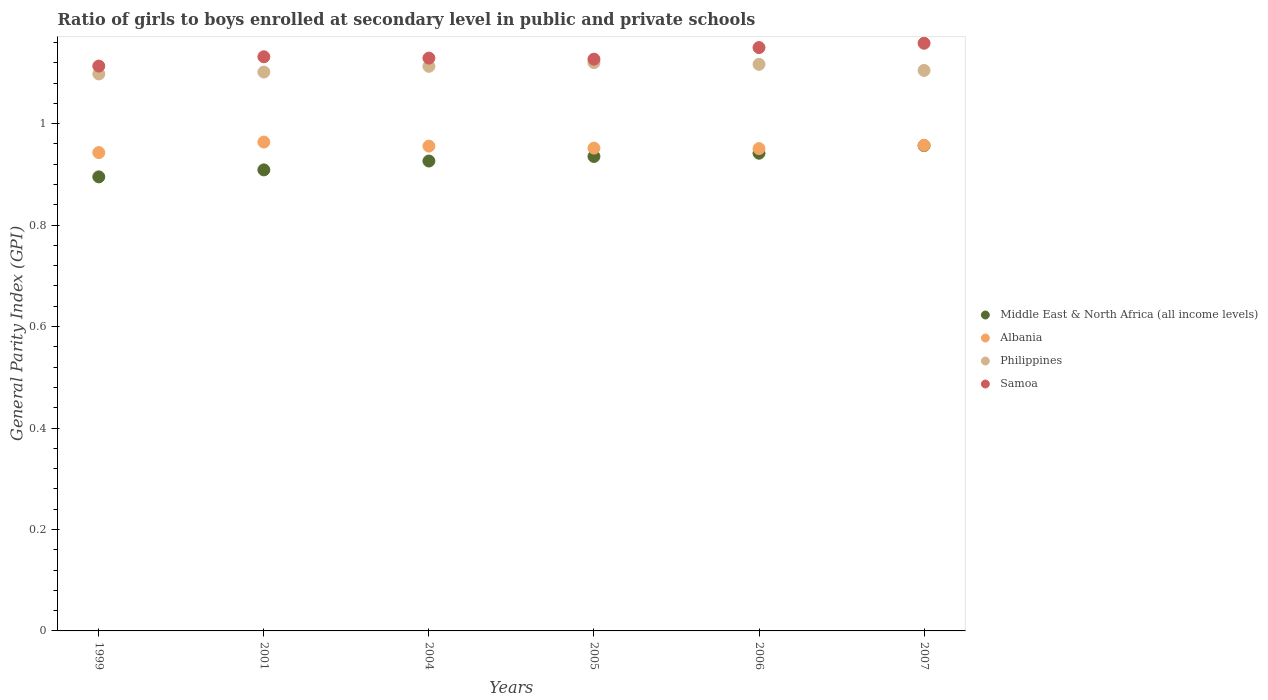What is the general parity index in Samoa in 2005?
Your answer should be compact. 1.13. Across all years, what is the maximum general parity index in Middle East & North Africa (all income levels)?
Your answer should be compact. 0.96. Across all years, what is the minimum general parity index in Middle East & North Africa (all income levels)?
Your answer should be compact. 0.9. What is the total general parity index in Middle East & North Africa (all income levels) in the graph?
Your response must be concise. 5.56. What is the difference between the general parity index in Samoa in 2006 and that in 2007?
Give a very brief answer. -0.01. What is the difference between the general parity index in Philippines in 2005 and the general parity index in Albania in 2007?
Make the answer very short. 0.16. What is the average general parity index in Albania per year?
Offer a very short reply. 0.95. In the year 1999, what is the difference between the general parity index in Philippines and general parity index in Samoa?
Keep it short and to the point. -0.02. What is the ratio of the general parity index in Middle East & North Africa (all income levels) in 2004 to that in 2007?
Your response must be concise. 0.97. Is the general parity index in Middle East & North Africa (all income levels) in 2001 less than that in 2004?
Make the answer very short. Yes. Is the difference between the general parity index in Philippines in 2005 and 2007 greater than the difference between the general parity index in Samoa in 2005 and 2007?
Provide a short and direct response. Yes. What is the difference between the highest and the second highest general parity index in Philippines?
Provide a short and direct response. 0. What is the difference between the highest and the lowest general parity index in Middle East & North Africa (all income levels)?
Provide a succinct answer. 0.06. Is the sum of the general parity index in Philippines in 1999 and 2005 greater than the maximum general parity index in Albania across all years?
Ensure brevity in your answer.  Yes. Is it the case that in every year, the sum of the general parity index in Samoa and general parity index in Philippines  is greater than the sum of general parity index in Middle East & North Africa (all income levels) and general parity index in Albania?
Ensure brevity in your answer.  No. Is the general parity index in Albania strictly greater than the general parity index in Philippines over the years?
Give a very brief answer. No. How many dotlines are there?
Ensure brevity in your answer.  4. Are the values on the major ticks of Y-axis written in scientific E-notation?
Keep it short and to the point. No. Does the graph contain any zero values?
Offer a very short reply. No. Does the graph contain grids?
Provide a succinct answer. No. How many legend labels are there?
Your answer should be very brief. 4. How are the legend labels stacked?
Your answer should be very brief. Vertical. What is the title of the graph?
Give a very brief answer. Ratio of girls to boys enrolled at secondary level in public and private schools. Does "Syrian Arab Republic" appear as one of the legend labels in the graph?
Your answer should be compact. No. What is the label or title of the X-axis?
Offer a terse response. Years. What is the label or title of the Y-axis?
Provide a succinct answer. General Parity Index (GPI). What is the General Parity Index (GPI) in Middle East & North Africa (all income levels) in 1999?
Provide a succinct answer. 0.9. What is the General Parity Index (GPI) in Albania in 1999?
Your response must be concise. 0.94. What is the General Parity Index (GPI) in Philippines in 1999?
Keep it short and to the point. 1.1. What is the General Parity Index (GPI) of Samoa in 1999?
Provide a short and direct response. 1.11. What is the General Parity Index (GPI) of Middle East & North Africa (all income levels) in 2001?
Your response must be concise. 0.91. What is the General Parity Index (GPI) of Albania in 2001?
Keep it short and to the point. 0.96. What is the General Parity Index (GPI) of Philippines in 2001?
Your answer should be very brief. 1.1. What is the General Parity Index (GPI) of Samoa in 2001?
Give a very brief answer. 1.13. What is the General Parity Index (GPI) in Middle East & North Africa (all income levels) in 2004?
Your response must be concise. 0.93. What is the General Parity Index (GPI) of Albania in 2004?
Provide a short and direct response. 0.96. What is the General Parity Index (GPI) in Philippines in 2004?
Your response must be concise. 1.11. What is the General Parity Index (GPI) in Samoa in 2004?
Offer a terse response. 1.13. What is the General Parity Index (GPI) of Middle East & North Africa (all income levels) in 2005?
Give a very brief answer. 0.94. What is the General Parity Index (GPI) in Albania in 2005?
Ensure brevity in your answer.  0.95. What is the General Parity Index (GPI) of Philippines in 2005?
Provide a succinct answer. 1.12. What is the General Parity Index (GPI) of Samoa in 2005?
Ensure brevity in your answer.  1.13. What is the General Parity Index (GPI) of Middle East & North Africa (all income levels) in 2006?
Your answer should be compact. 0.94. What is the General Parity Index (GPI) of Albania in 2006?
Give a very brief answer. 0.95. What is the General Parity Index (GPI) in Philippines in 2006?
Your answer should be very brief. 1.12. What is the General Parity Index (GPI) in Samoa in 2006?
Your answer should be very brief. 1.15. What is the General Parity Index (GPI) of Middle East & North Africa (all income levels) in 2007?
Make the answer very short. 0.96. What is the General Parity Index (GPI) in Albania in 2007?
Offer a terse response. 0.96. What is the General Parity Index (GPI) in Philippines in 2007?
Provide a succinct answer. 1.1. What is the General Parity Index (GPI) of Samoa in 2007?
Offer a very short reply. 1.16. Across all years, what is the maximum General Parity Index (GPI) of Middle East & North Africa (all income levels)?
Keep it short and to the point. 0.96. Across all years, what is the maximum General Parity Index (GPI) of Albania?
Keep it short and to the point. 0.96. Across all years, what is the maximum General Parity Index (GPI) in Philippines?
Your answer should be compact. 1.12. Across all years, what is the maximum General Parity Index (GPI) of Samoa?
Ensure brevity in your answer.  1.16. Across all years, what is the minimum General Parity Index (GPI) of Middle East & North Africa (all income levels)?
Offer a very short reply. 0.9. Across all years, what is the minimum General Parity Index (GPI) of Albania?
Keep it short and to the point. 0.94. Across all years, what is the minimum General Parity Index (GPI) of Philippines?
Give a very brief answer. 1.1. Across all years, what is the minimum General Parity Index (GPI) of Samoa?
Your answer should be very brief. 1.11. What is the total General Parity Index (GPI) of Middle East & North Africa (all income levels) in the graph?
Make the answer very short. 5.56. What is the total General Parity Index (GPI) of Albania in the graph?
Keep it short and to the point. 5.72. What is the total General Parity Index (GPI) in Philippines in the graph?
Keep it short and to the point. 6.65. What is the total General Parity Index (GPI) of Samoa in the graph?
Offer a very short reply. 6.81. What is the difference between the General Parity Index (GPI) of Middle East & North Africa (all income levels) in 1999 and that in 2001?
Provide a succinct answer. -0.01. What is the difference between the General Parity Index (GPI) of Albania in 1999 and that in 2001?
Your response must be concise. -0.02. What is the difference between the General Parity Index (GPI) in Philippines in 1999 and that in 2001?
Your response must be concise. -0. What is the difference between the General Parity Index (GPI) of Samoa in 1999 and that in 2001?
Make the answer very short. -0.02. What is the difference between the General Parity Index (GPI) in Middle East & North Africa (all income levels) in 1999 and that in 2004?
Provide a short and direct response. -0.03. What is the difference between the General Parity Index (GPI) in Albania in 1999 and that in 2004?
Your answer should be very brief. -0.01. What is the difference between the General Parity Index (GPI) of Philippines in 1999 and that in 2004?
Your answer should be very brief. -0.01. What is the difference between the General Parity Index (GPI) of Samoa in 1999 and that in 2004?
Offer a very short reply. -0.02. What is the difference between the General Parity Index (GPI) of Middle East & North Africa (all income levels) in 1999 and that in 2005?
Provide a succinct answer. -0.04. What is the difference between the General Parity Index (GPI) of Albania in 1999 and that in 2005?
Offer a terse response. -0.01. What is the difference between the General Parity Index (GPI) in Philippines in 1999 and that in 2005?
Offer a terse response. -0.02. What is the difference between the General Parity Index (GPI) of Samoa in 1999 and that in 2005?
Your answer should be compact. -0.01. What is the difference between the General Parity Index (GPI) in Middle East & North Africa (all income levels) in 1999 and that in 2006?
Keep it short and to the point. -0.05. What is the difference between the General Parity Index (GPI) in Albania in 1999 and that in 2006?
Ensure brevity in your answer.  -0.01. What is the difference between the General Parity Index (GPI) in Philippines in 1999 and that in 2006?
Make the answer very short. -0.02. What is the difference between the General Parity Index (GPI) of Samoa in 1999 and that in 2006?
Make the answer very short. -0.04. What is the difference between the General Parity Index (GPI) in Middle East & North Africa (all income levels) in 1999 and that in 2007?
Make the answer very short. -0.06. What is the difference between the General Parity Index (GPI) in Albania in 1999 and that in 2007?
Provide a short and direct response. -0.01. What is the difference between the General Parity Index (GPI) of Philippines in 1999 and that in 2007?
Provide a short and direct response. -0.01. What is the difference between the General Parity Index (GPI) in Samoa in 1999 and that in 2007?
Ensure brevity in your answer.  -0.04. What is the difference between the General Parity Index (GPI) in Middle East & North Africa (all income levels) in 2001 and that in 2004?
Provide a succinct answer. -0.02. What is the difference between the General Parity Index (GPI) of Albania in 2001 and that in 2004?
Your response must be concise. 0.01. What is the difference between the General Parity Index (GPI) of Philippines in 2001 and that in 2004?
Keep it short and to the point. -0.01. What is the difference between the General Parity Index (GPI) of Samoa in 2001 and that in 2004?
Keep it short and to the point. 0. What is the difference between the General Parity Index (GPI) in Middle East & North Africa (all income levels) in 2001 and that in 2005?
Keep it short and to the point. -0.03. What is the difference between the General Parity Index (GPI) in Albania in 2001 and that in 2005?
Offer a terse response. 0.01. What is the difference between the General Parity Index (GPI) of Philippines in 2001 and that in 2005?
Give a very brief answer. -0.02. What is the difference between the General Parity Index (GPI) of Samoa in 2001 and that in 2005?
Provide a short and direct response. 0. What is the difference between the General Parity Index (GPI) of Middle East & North Africa (all income levels) in 2001 and that in 2006?
Offer a very short reply. -0.03. What is the difference between the General Parity Index (GPI) in Albania in 2001 and that in 2006?
Offer a very short reply. 0.01. What is the difference between the General Parity Index (GPI) of Philippines in 2001 and that in 2006?
Ensure brevity in your answer.  -0.02. What is the difference between the General Parity Index (GPI) of Samoa in 2001 and that in 2006?
Keep it short and to the point. -0.02. What is the difference between the General Parity Index (GPI) of Middle East & North Africa (all income levels) in 2001 and that in 2007?
Give a very brief answer. -0.05. What is the difference between the General Parity Index (GPI) of Albania in 2001 and that in 2007?
Your response must be concise. 0.01. What is the difference between the General Parity Index (GPI) in Philippines in 2001 and that in 2007?
Your answer should be very brief. -0. What is the difference between the General Parity Index (GPI) in Samoa in 2001 and that in 2007?
Offer a very short reply. -0.03. What is the difference between the General Parity Index (GPI) of Middle East & North Africa (all income levels) in 2004 and that in 2005?
Your response must be concise. -0.01. What is the difference between the General Parity Index (GPI) of Albania in 2004 and that in 2005?
Make the answer very short. 0. What is the difference between the General Parity Index (GPI) of Philippines in 2004 and that in 2005?
Your response must be concise. -0.01. What is the difference between the General Parity Index (GPI) in Samoa in 2004 and that in 2005?
Provide a succinct answer. 0. What is the difference between the General Parity Index (GPI) of Middle East & North Africa (all income levels) in 2004 and that in 2006?
Keep it short and to the point. -0.02. What is the difference between the General Parity Index (GPI) in Albania in 2004 and that in 2006?
Your answer should be very brief. 0. What is the difference between the General Parity Index (GPI) in Philippines in 2004 and that in 2006?
Your answer should be compact. -0. What is the difference between the General Parity Index (GPI) in Samoa in 2004 and that in 2006?
Ensure brevity in your answer.  -0.02. What is the difference between the General Parity Index (GPI) of Middle East & North Africa (all income levels) in 2004 and that in 2007?
Your response must be concise. -0.03. What is the difference between the General Parity Index (GPI) of Albania in 2004 and that in 2007?
Your answer should be very brief. -0. What is the difference between the General Parity Index (GPI) in Philippines in 2004 and that in 2007?
Offer a terse response. 0.01. What is the difference between the General Parity Index (GPI) in Samoa in 2004 and that in 2007?
Ensure brevity in your answer.  -0.03. What is the difference between the General Parity Index (GPI) of Middle East & North Africa (all income levels) in 2005 and that in 2006?
Your answer should be very brief. -0.01. What is the difference between the General Parity Index (GPI) in Albania in 2005 and that in 2006?
Your response must be concise. 0. What is the difference between the General Parity Index (GPI) of Philippines in 2005 and that in 2006?
Your answer should be compact. 0. What is the difference between the General Parity Index (GPI) in Samoa in 2005 and that in 2006?
Make the answer very short. -0.02. What is the difference between the General Parity Index (GPI) in Middle East & North Africa (all income levels) in 2005 and that in 2007?
Give a very brief answer. -0.02. What is the difference between the General Parity Index (GPI) of Albania in 2005 and that in 2007?
Ensure brevity in your answer.  -0.01. What is the difference between the General Parity Index (GPI) of Philippines in 2005 and that in 2007?
Provide a succinct answer. 0.02. What is the difference between the General Parity Index (GPI) of Samoa in 2005 and that in 2007?
Keep it short and to the point. -0.03. What is the difference between the General Parity Index (GPI) in Middle East & North Africa (all income levels) in 2006 and that in 2007?
Offer a terse response. -0.01. What is the difference between the General Parity Index (GPI) of Albania in 2006 and that in 2007?
Give a very brief answer. -0.01. What is the difference between the General Parity Index (GPI) of Philippines in 2006 and that in 2007?
Give a very brief answer. 0.01. What is the difference between the General Parity Index (GPI) of Samoa in 2006 and that in 2007?
Provide a succinct answer. -0.01. What is the difference between the General Parity Index (GPI) in Middle East & North Africa (all income levels) in 1999 and the General Parity Index (GPI) in Albania in 2001?
Keep it short and to the point. -0.07. What is the difference between the General Parity Index (GPI) of Middle East & North Africa (all income levels) in 1999 and the General Parity Index (GPI) of Philippines in 2001?
Your answer should be compact. -0.21. What is the difference between the General Parity Index (GPI) of Middle East & North Africa (all income levels) in 1999 and the General Parity Index (GPI) of Samoa in 2001?
Provide a short and direct response. -0.24. What is the difference between the General Parity Index (GPI) of Albania in 1999 and the General Parity Index (GPI) of Philippines in 2001?
Ensure brevity in your answer.  -0.16. What is the difference between the General Parity Index (GPI) of Albania in 1999 and the General Parity Index (GPI) of Samoa in 2001?
Make the answer very short. -0.19. What is the difference between the General Parity Index (GPI) of Philippines in 1999 and the General Parity Index (GPI) of Samoa in 2001?
Make the answer very short. -0.03. What is the difference between the General Parity Index (GPI) in Middle East & North Africa (all income levels) in 1999 and the General Parity Index (GPI) in Albania in 2004?
Ensure brevity in your answer.  -0.06. What is the difference between the General Parity Index (GPI) in Middle East & North Africa (all income levels) in 1999 and the General Parity Index (GPI) in Philippines in 2004?
Ensure brevity in your answer.  -0.22. What is the difference between the General Parity Index (GPI) of Middle East & North Africa (all income levels) in 1999 and the General Parity Index (GPI) of Samoa in 2004?
Make the answer very short. -0.23. What is the difference between the General Parity Index (GPI) of Albania in 1999 and the General Parity Index (GPI) of Philippines in 2004?
Give a very brief answer. -0.17. What is the difference between the General Parity Index (GPI) in Albania in 1999 and the General Parity Index (GPI) in Samoa in 2004?
Keep it short and to the point. -0.19. What is the difference between the General Parity Index (GPI) in Philippines in 1999 and the General Parity Index (GPI) in Samoa in 2004?
Provide a succinct answer. -0.03. What is the difference between the General Parity Index (GPI) of Middle East & North Africa (all income levels) in 1999 and the General Parity Index (GPI) of Albania in 2005?
Make the answer very short. -0.06. What is the difference between the General Parity Index (GPI) in Middle East & North Africa (all income levels) in 1999 and the General Parity Index (GPI) in Philippines in 2005?
Offer a very short reply. -0.23. What is the difference between the General Parity Index (GPI) of Middle East & North Africa (all income levels) in 1999 and the General Parity Index (GPI) of Samoa in 2005?
Give a very brief answer. -0.23. What is the difference between the General Parity Index (GPI) in Albania in 1999 and the General Parity Index (GPI) in Philippines in 2005?
Your answer should be compact. -0.18. What is the difference between the General Parity Index (GPI) in Albania in 1999 and the General Parity Index (GPI) in Samoa in 2005?
Offer a terse response. -0.18. What is the difference between the General Parity Index (GPI) of Philippines in 1999 and the General Parity Index (GPI) of Samoa in 2005?
Give a very brief answer. -0.03. What is the difference between the General Parity Index (GPI) in Middle East & North Africa (all income levels) in 1999 and the General Parity Index (GPI) in Albania in 2006?
Offer a terse response. -0.06. What is the difference between the General Parity Index (GPI) of Middle East & North Africa (all income levels) in 1999 and the General Parity Index (GPI) of Philippines in 2006?
Offer a terse response. -0.22. What is the difference between the General Parity Index (GPI) of Middle East & North Africa (all income levels) in 1999 and the General Parity Index (GPI) of Samoa in 2006?
Provide a succinct answer. -0.25. What is the difference between the General Parity Index (GPI) in Albania in 1999 and the General Parity Index (GPI) in Philippines in 2006?
Make the answer very short. -0.17. What is the difference between the General Parity Index (GPI) in Albania in 1999 and the General Parity Index (GPI) in Samoa in 2006?
Your response must be concise. -0.21. What is the difference between the General Parity Index (GPI) in Philippines in 1999 and the General Parity Index (GPI) in Samoa in 2006?
Offer a very short reply. -0.05. What is the difference between the General Parity Index (GPI) of Middle East & North Africa (all income levels) in 1999 and the General Parity Index (GPI) of Albania in 2007?
Provide a short and direct response. -0.06. What is the difference between the General Parity Index (GPI) in Middle East & North Africa (all income levels) in 1999 and the General Parity Index (GPI) in Philippines in 2007?
Your answer should be compact. -0.21. What is the difference between the General Parity Index (GPI) of Middle East & North Africa (all income levels) in 1999 and the General Parity Index (GPI) of Samoa in 2007?
Keep it short and to the point. -0.26. What is the difference between the General Parity Index (GPI) in Albania in 1999 and the General Parity Index (GPI) in Philippines in 2007?
Provide a short and direct response. -0.16. What is the difference between the General Parity Index (GPI) in Albania in 1999 and the General Parity Index (GPI) in Samoa in 2007?
Provide a short and direct response. -0.22. What is the difference between the General Parity Index (GPI) of Philippines in 1999 and the General Parity Index (GPI) of Samoa in 2007?
Your response must be concise. -0.06. What is the difference between the General Parity Index (GPI) in Middle East & North Africa (all income levels) in 2001 and the General Parity Index (GPI) in Albania in 2004?
Provide a short and direct response. -0.05. What is the difference between the General Parity Index (GPI) in Middle East & North Africa (all income levels) in 2001 and the General Parity Index (GPI) in Philippines in 2004?
Keep it short and to the point. -0.2. What is the difference between the General Parity Index (GPI) in Middle East & North Africa (all income levels) in 2001 and the General Parity Index (GPI) in Samoa in 2004?
Offer a very short reply. -0.22. What is the difference between the General Parity Index (GPI) of Albania in 2001 and the General Parity Index (GPI) of Philippines in 2004?
Offer a very short reply. -0.15. What is the difference between the General Parity Index (GPI) of Albania in 2001 and the General Parity Index (GPI) of Samoa in 2004?
Your response must be concise. -0.17. What is the difference between the General Parity Index (GPI) in Philippines in 2001 and the General Parity Index (GPI) in Samoa in 2004?
Offer a terse response. -0.03. What is the difference between the General Parity Index (GPI) of Middle East & North Africa (all income levels) in 2001 and the General Parity Index (GPI) of Albania in 2005?
Provide a short and direct response. -0.04. What is the difference between the General Parity Index (GPI) of Middle East & North Africa (all income levels) in 2001 and the General Parity Index (GPI) of Philippines in 2005?
Keep it short and to the point. -0.21. What is the difference between the General Parity Index (GPI) of Middle East & North Africa (all income levels) in 2001 and the General Parity Index (GPI) of Samoa in 2005?
Make the answer very short. -0.22. What is the difference between the General Parity Index (GPI) of Albania in 2001 and the General Parity Index (GPI) of Philippines in 2005?
Provide a succinct answer. -0.16. What is the difference between the General Parity Index (GPI) of Albania in 2001 and the General Parity Index (GPI) of Samoa in 2005?
Offer a terse response. -0.16. What is the difference between the General Parity Index (GPI) in Philippines in 2001 and the General Parity Index (GPI) in Samoa in 2005?
Provide a short and direct response. -0.03. What is the difference between the General Parity Index (GPI) in Middle East & North Africa (all income levels) in 2001 and the General Parity Index (GPI) in Albania in 2006?
Offer a very short reply. -0.04. What is the difference between the General Parity Index (GPI) of Middle East & North Africa (all income levels) in 2001 and the General Parity Index (GPI) of Philippines in 2006?
Your answer should be compact. -0.21. What is the difference between the General Parity Index (GPI) in Middle East & North Africa (all income levels) in 2001 and the General Parity Index (GPI) in Samoa in 2006?
Your answer should be very brief. -0.24. What is the difference between the General Parity Index (GPI) in Albania in 2001 and the General Parity Index (GPI) in Philippines in 2006?
Give a very brief answer. -0.15. What is the difference between the General Parity Index (GPI) of Albania in 2001 and the General Parity Index (GPI) of Samoa in 2006?
Your response must be concise. -0.19. What is the difference between the General Parity Index (GPI) of Philippines in 2001 and the General Parity Index (GPI) of Samoa in 2006?
Offer a very short reply. -0.05. What is the difference between the General Parity Index (GPI) in Middle East & North Africa (all income levels) in 2001 and the General Parity Index (GPI) in Albania in 2007?
Offer a terse response. -0.05. What is the difference between the General Parity Index (GPI) in Middle East & North Africa (all income levels) in 2001 and the General Parity Index (GPI) in Philippines in 2007?
Provide a succinct answer. -0.2. What is the difference between the General Parity Index (GPI) in Middle East & North Africa (all income levels) in 2001 and the General Parity Index (GPI) in Samoa in 2007?
Keep it short and to the point. -0.25. What is the difference between the General Parity Index (GPI) of Albania in 2001 and the General Parity Index (GPI) of Philippines in 2007?
Offer a very short reply. -0.14. What is the difference between the General Parity Index (GPI) of Albania in 2001 and the General Parity Index (GPI) of Samoa in 2007?
Offer a very short reply. -0.19. What is the difference between the General Parity Index (GPI) in Philippines in 2001 and the General Parity Index (GPI) in Samoa in 2007?
Keep it short and to the point. -0.06. What is the difference between the General Parity Index (GPI) of Middle East & North Africa (all income levels) in 2004 and the General Parity Index (GPI) of Albania in 2005?
Your answer should be very brief. -0.03. What is the difference between the General Parity Index (GPI) of Middle East & North Africa (all income levels) in 2004 and the General Parity Index (GPI) of Philippines in 2005?
Your response must be concise. -0.19. What is the difference between the General Parity Index (GPI) in Middle East & North Africa (all income levels) in 2004 and the General Parity Index (GPI) in Samoa in 2005?
Ensure brevity in your answer.  -0.2. What is the difference between the General Parity Index (GPI) in Albania in 2004 and the General Parity Index (GPI) in Philippines in 2005?
Your answer should be very brief. -0.16. What is the difference between the General Parity Index (GPI) of Albania in 2004 and the General Parity Index (GPI) of Samoa in 2005?
Your answer should be very brief. -0.17. What is the difference between the General Parity Index (GPI) of Philippines in 2004 and the General Parity Index (GPI) of Samoa in 2005?
Give a very brief answer. -0.01. What is the difference between the General Parity Index (GPI) in Middle East & North Africa (all income levels) in 2004 and the General Parity Index (GPI) in Albania in 2006?
Provide a succinct answer. -0.02. What is the difference between the General Parity Index (GPI) in Middle East & North Africa (all income levels) in 2004 and the General Parity Index (GPI) in Philippines in 2006?
Make the answer very short. -0.19. What is the difference between the General Parity Index (GPI) in Middle East & North Africa (all income levels) in 2004 and the General Parity Index (GPI) in Samoa in 2006?
Ensure brevity in your answer.  -0.22. What is the difference between the General Parity Index (GPI) of Albania in 2004 and the General Parity Index (GPI) of Philippines in 2006?
Your answer should be compact. -0.16. What is the difference between the General Parity Index (GPI) in Albania in 2004 and the General Parity Index (GPI) in Samoa in 2006?
Provide a short and direct response. -0.19. What is the difference between the General Parity Index (GPI) of Philippines in 2004 and the General Parity Index (GPI) of Samoa in 2006?
Offer a very short reply. -0.04. What is the difference between the General Parity Index (GPI) in Middle East & North Africa (all income levels) in 2004 and the General Parity Index (GPI) in Albania in 2007?
Ensure brevity in your answer.  -0.03. What is the difference between the General Parity Index (GPI) of Middle East & North Africa (all income levels) in 2004 and the General Parity Index (GPI) of Philippines in 2007?
Make the answer very short. -0.18. What is the difference between the General Parity Index (GPI) of Middle East & North Africa (all income levels) in 2004 and the General Parity Index (GPI) of Samoa in 2007?
Make the answer very short. -0.23. What is the difference between the General Parity Index (GPI) of Albania in 2004 and the General Parity Index (GPI) of Philippines in 2007?
Your answer should be very brief. -0.15. What is the difference between the General Parity Index (GPI) in Albania in 2004 and the General Parity Index (GPI) in Samoa in 2007?
Offer a very short reply. -0.2. What is the difference between the General Parity Index (GPI) in Philippines in 2004 and the General Parity Index (GPI) in Samoa in 2007?
Keep it short and to the point. -0.05. What is the difference between the General Parity Index (GPI) of Middle East & North Africa (all income levels) in 2005 and the General Parity Index (GPI) of Albania in 2006?
Provide a succinct answer. -0.02. What is the difference between the General Parity Index (GPI) in Middle East & North Africa (all income levels) in 2005 and the General Parity Index (GPI) in Philippines in 2006?
Provide a short and direct response. -0.18. What is the difference between the General Parity Index (GPI) in Middle East & North Africa (all income levels) in 2005 and the General Parity Index (GPI) in Samoa in 2006?
Offer a terse response. -0.21. What is the difference between the General Parity Index (GPI) of Albania in 2005 and the General Parity Index (GPI) of Philippines in 2006?
Provide a succinct answer. -0.17. What is the difference between the General Parity Index (GPI) in Albania in 2005 and the General Parity Index (GPI) in Samoa in 2006?
Offer a very short reply. -0.2. What is the difference between the General Parity Index (GPI) of Philippines in 2005 and the General Parity Index (GPI) of Samoa in 2006?
Keep it short and to the point. -0.03. What is the difference between the General Parity Index (GPI) in Middle East & North Africa (all income levels) in 2005 and the General Parity Index (GPI) in Albania in 2007?
Provide a succinct answer. -0.02. What is the difference between the General Parity Index (GPI) in Middle East & North Africa (all income levels) in 2005 and the General Parity Index (GPI) in Philippines in 2007?
Your answer should be compact. -0.17. What is the difference between the General Parity Index (GPI) in Middle East & North Africa (all income levels) in 2005 and the General Parity Index (GPI) in Samoa in 2007?
Keep it short and to the point. -0.22. What is the difference between the General Parity Index (GPI) in Albania in 2005 and the General Parity Index (GPI) in Philippines in 2007?
Your answer should be very brief. -0.15. What is the difference between the General Parity Index (GPI) in Albania in 2005 and the General Parity Index (GPI) in Samoa in 2007?
Your response must be concise. -0.21. What is the difference between the General Parity Index (GPI) in Philippines in 2005 and the General Parity Index (GPI) in Samoa in 2007?
Make the answer very short. -0.04. What is the difference between the General Parity Index (GPI) of Middle East & North Africa (all income levels) in 2006 and the General Parity Index (GPI) of Albania in 2007?
Give a very brief answer. -0.02. What is the difference between the General Parity Index (GPI) in Middle East & North Africa (all income levels) in 2006 and the General Parity Index (GPI) in Philippines in 2007?
Your answer should be compact. -0.16. What is the difference between the General Parity Index (GPI) in Middle East & North Africa (all income levels) in 2006 and the General Parity Index (GPI) in Samoa in 2007?
Offer a very short reply. -0.22. What is the difference between the General Parity Index (GPI) of Albania in 2006 and the General Parity Index (GPI) of Philippines in 2007?
Offer a terse response. -0.15. What is the difference between the General Parity Index (GPI) in Albania in 2006 and the General Parity Index (GPI) in Samoa in 2007?
Provide a short and direct response. -0.21. What is the difference between the General Parity Index (GPI) of Philippines in 2006 and the General Parity Index (GPI) of Samoa in 2007?
Keep it short and to the point. -0.04. What is the average General Parity Index (GPI) in Middle East & North Africa (all income levels) per year?
Provide a short and direct response. 0.93. What is the average General Parity Index (GPI) in Albania per year?
Your answer should be very brief. 0.95. What is the average General Parity Index (GPI) in Philippines per year?
Offer a very short reply. 1.11. What is the average General Parity Index (GPI) of Samoa per year?
Your answer should be very brief. 1.14. In the year 1999, what is the difference between the General Parity Index (GPI) of Middle East & North Africa (all income levels) and General Parity Index (GPI) of Albania?
Keep it short and to the point. -0.05. In the year 1999, what is the difference between the General Parity Index (GPI) in Middle East & North Africa (all income levels) and General Parity Index (GPI) in Philippines?
Provide a succinct answer. -0.2. In the year 1999, what is the difference between the General Parity Index (GPI) of Middle East & North Africa (all income levels) and General Parity Index (GPI) of Samoa?
Your response must be concise. -0.22. In the year 1999, what is the difference between the General Parity Index (GPI) of Albania and General Parity Index (GPI) of Philippines?
Provide a succinct answer. -0.15. In the year 1999, what is the difference between the General Parity Index (GPI) in Albania and General Parity Index (GPI) in Samoa?
Your response must be concise. -0.17. In the year 1999, what is the difference between the General Parity Index (GPI) of Philippines and General Parity Index (GPI) of Samoa?
Offer a very short reply. -0.02. In the year 2001, what is the difference between the General Parity Index (GPI) of Middle East & North Africa (all income levels) and General Parity Index (GPI) of Albania?
Offer a very short reply. -0.05. In the year 2001, what is the difference between the General Parity Index (GPI) of Middle East & North Africa (all income levels) and General Parity Index (GPI) of Philippines?
Provide a short and direct response. -0.19. In the year 2001, what is the difference between the General Parity Index (GPI) in Middle East & North Africa (all income levels) and General Parity Index (GPI) in Samoa?
Offer a terse response. -0.22. In the year 2001, what is the difference between the General Parity Index (GPI) of Albania and General Parity Index (GPI) of Philippines?
Make the answer very short. -0.14. In the year 2001, what is the difference between the General Parity Index (GPI) in Albania and General Parity Index (GPI) in Samoa?
Provide a short and direct response. -0.17. In the year 2001, what is the difference between the General Parity Index (GPI) of Philippines and General Parity Index (GPI) of Samoa?
Give a very brief answer. -0.03. In the year 2004, what is the difference between the General Parity Index (GPI) in Middle East & North Africa (all income levels) and General Parity Index (GPI) in Albania?
Give a very brief answer. -0.03. In the year 2004, what is the difference between the General Parity Index (GPI) of Middle East & North Africa (all income levels) and General Parity Index (GPI) of Philippines?
Ensure brevity in your answer.  -0.19. In the year 2004, what is the difference between the General Parity Index (GPI) of Middle East & North Africa (all income levels) and General Parity Index (GPI) of Samoa?
Offer a very short reply. -0.2. In the year 2004, what is the difference between the General Parity Index (GPI) of Albania and General Parity Index (GPI) of Philippines?
Give a very brief answer. -0.16. In the year 2004, what is the difference between the General Parity Index (GPI) in Albania and General Parity Index (GPI) in Samoa?
Your answer should be compact. -0.17. In the year 2004, what is the difference between the General Parity Index (GPI) in Philippines and General Parity Index (GPI) in Samoa?
Provide a succinct answer. -0.02. In the year 2005, what is the difference between the General Parity Index (GPI) in Middle East & North Africa (all income levels) and General Parity Index (GPI) in Albania?
Keep it short and to the point. -0.02. In the year 2005, what is the difference between the General Parity Index (GPI) of Middle East & North Africa (all income levels) and General Parity Index (GPI) of Philippines?
Make the answer very short. -0.18. In the year 2005, what is the difference between the General Parity Index (GPI) in Middle East & North Africa (all income levels) and General Parity Index (GPI) in Samoa?
Keep it short and to the point. -0.19. In the year 2005, what is the difference between the General Parity Index (GPI) in Albania and General Parity Index (GPI) in Philippines?
Keep it short and to the point. -0.17. In the year 2005, what is the difference between the General Parity Index (GPI) in Albania and General Parity Index (GPI) in Samoa?
Ensure brevity in your answer.  -0.18. In the year 2005, what is the difference between the General Parity Index (GPI) of Philippines and General Parity Index (GPI) of Samoa?
Offer a very short reply. -0.01. In the year 2006, what is the difference between the General Parity Index (GPI) in Middle East & North Africa (all income levels) and General Parity Index (GPI) in Albania?
Your response must be concise. -0.01. In the year 2006, what is the difference between the General Parity Index (GPI) of Middle East & North Africa (all income levels) and General Parity Index (GPI) of Philippines?
Make the answer very short. -0.18. In the year 2006, what is the difference between the General Parity Index (GPI) of Middle East & North Africa (all income levels) and General Parity Index (GPI) of Samoa?
Ensure brevity in your answer.  -0.21. In the year 2006, what is the difference between the General Parity Index (GPI) in Albania and General Parity Index (GPI) in Philippines?
Ensure brevity in your answer.  -0.17. In the year 2006, what is the difference between the General Parity Index (GPI) in Albania and General Parity Index (GPI) in Samoa?
Your answer should be compact. -0.2. In the year 2006, what is the difference between the General Parity Index (GPI) in Philippines and General Parity Index (GPI) in Samoa?
Make the answer very short. -0.03. In the year 2007, what is the difference between the General Parity Index (GPI) in Middle East & North Africa (all income levels) and General Parity Index (GPI) in Albania?
Keep it short and to the point. -0. In the year 2007, what is the difference between the General Parity Index (GPI) in Middle East & North Africa (all income levels) and General Parity Index (GPI) in Philippines?
Make the answer very short. -0.15. In the year 2007, what is the difference between the General Parity Index (GPI) of Middle East & North Africa (all income levels) and General Parity Index (GPI) of Samoa?
Offer a very short reply. -0.2. In the year 2007, what is the difference between the General Parity Index (GPI) of Albania and General Parity Index (GPI) of Philippines?
Offer a terse response. -0.15. In the year 2007, what is the difference between the General Parity Index (GPI) of Albania and General Parity Index (GPI) of Samoa?
Make the answer very short. -0.2. In the year 2007, what is the difference between the General Parity Index (GPI) of Philippines and General Parity Index (GPI) of Samoa?
Your response must be concise. -0.05. What is the ratio of the General Parity Index (GPI) in Albania in 1999 to that in 2001?
Your response must be concise. 0.98. What is the ratio of the General Parity Index (GPI) in Samoa in 1999 to that in 2001?
Your response must be concise. 0.98. What is the ratio of the General Parity Index (GPI) in Middle East & North Africa (all income levels) in 1999 to that in 2004?
Your response must be concise. 0.97. What is the ratio of the General Parity Index (GPI) in Albania in 1999 to that in 2004?
Offer a very short reply. 0.99. What is the ratio of the General Parity Index (GPI) in Philippines in 1999 to that in 2004?
Make the answer very short. 0.99. What is the ratio of the General Parity Index (GPI) of Samoa in 1999 to that in 2004?
Ensure brevity in your answer.  0.99. What is the ratio of the General Parity Index (GPI) of Philippines in 1999 to that in 2005?
Keep it short and to the point. 0.98. What is the ratio of the General Parity Index (GPI) in Samoa in 1999 to that in 2005?
Your response must be concise. 0.99. What is the ratio of the General Parity Index (GPI) in Middle East & North Africa (all income levels) in 1999 to that in 2006?
Ensure brevity in your answer.  0.95. What is the ratio of the General Parity Index (GPI) in Albania in 1999 to that in 2006?
Keep it short and to the point. 0.99. What is the ratio of the General Parity Index (GPI) of Samoa in 1999 to that in 2006?
Keep it short and to the point. 0.97. What is the ratio of the General Parity Index (GPI) of Middle East & North Africa (all income levels) in 1999 to that in 2007?
Offer a terse response. 0.94. What is the ratio of the General Parity Index (GPI) in Albania in 1999 to that in 2007?
Your response must be concise. 0.98. What is the ratio of the General Parity Index (GPI) of Samoa in 1999 to that in 2007?
Your response must be concise. 0.96. What is the ratio of the General Parity Index (GPI) in Middle East & North Africa (all income levels) in 2001 to that in 2004?
Offer a very short reply. 0.98. What is the ratio of the General Parity Index (GPI) of Albania in 2001 to that in 2004?
Make the answer very short. 1.01. What is the ratio of the General Parity Index (GPI) in Philippines in 2001 to that in 2004?
Your answer should be very brief. 0.99. What is the ratio of the General Parity Index (GPI) of Middle East & North Africa (all income levels) in 2001 to that in 2005?
Keep it short and to the point. 0.97. What is the ratio of the General Parity Index (GPI) of Albania in 2001 to that in 2005?
Offer a terse response. 1.01. What is the ratio of the General Parity Index (GPI) in Philippines in 2001 to that in 2005?
Your response must be concise. 0.98. What is the ratio of the General Parity Index (GPI) of Samoa in 2001 to that in 2005?
Your answer should be very brief. 1. What is the ratio of the General Parity Index (GPI) in Middle East & North Africa (all income levels) in 2001 to that in 2006?
Ensure brevity in your answer.  0.97. What is the ratio of the General Parity Index (GPI) of Albania in 2001 to that in 2006?
Your response must be concise. 1.01. What is the ratio of the General Parity Index (GPI) of Philippines in 2001 to that in 2006?
Keep it short and to the point. 0.99. What is the ratio of the General Parity Index (GPI) in Samoa in 2001 to that in 2006?
Make the answer very short. 0.98. What is the ratio of the General Parity Index (GPI) in Middle East & North Africa (all income levels) in 2001 to that in 2007?
Ensure brevity in your answer.  0.95. What is the ratio of the General Parity Index (GPI) in Albania in 2001 to that in 2007?
Make the answer very short. 1.01. What is the ratio of the General Parity Index (GPI) in Samoa in 2001 to that in 2007?
Your answer should be compact. 0.98. What is the ratio of the General Parity Index (GPI) of Middle East & North Africa (all income levels) in 2004 to that in 2005?
Your response must be concise. 0.99. What is the ratio of the General Parity Index (GPI) in Albania in 2004 to that in 2005?
Give a very brief answer. 1. What is the ratio of the General Parity Index (GPI) in Philippines in 2004 to that in 2005?
Provide a succinct answer. 0.99. What is the ratio of the General Parity Index (GPI) of Samoa in 2004 to that in 2005?
Your answer should be compact. 1. What is the ratio of the General Parity Index (GPI) of Middle East & North Africa (all income levels) in 2004 to that in 2006?
Provide a succinct answer. 0.98. What is the ratio of the General Parity Index (GPI) of Albania in 2004 to that in 2006?
Your answer should be very brief. 1.01. What is the ratio of the General Parity Index (GPI) of Philippines in 2004 to that in 2006?
Ensure brevity in your answer.  1. What is the ratio of the General Parity Index (GPI) of Samoa in 2004 to that in 2006?
Make the answer very short. 0.98. What is the ratio of the General Parity Index (GPI) of Middle East & North Africa (all income levels) in 2004 to that in 2007?
Provide a short and direct response. 0.97. What is the ratio of the General Parity Index (GPI) of Albania in 2004 to that in 2007?
Make the answer very short. 1. What is the ratio of the General Parity Index (GPI) of Philippines in 2004 to that in 2007?
Provide a succinct answer. 1.01. What is the ratio of the General Parity Index (GPI) in Samoa in 2004 to that in 2007?
Provide a succinct answer. 0.97. What is the ratio of the General Parity Index (GPI) of Middle East & North Africa (all income levels) in 2005 to that in 2006?
Your answer should be compact. 0.99. What is the ratio of the General Parity Index (GPI) in Samoa in 2005 to that in 2006?
Keep it short and to the point. 0.98. What is the ratio of the General Parity Index (GPI) in Middle East & North Africa (all income levels) in 2005 to that in 2007?
Provide a short and direct response. 0.98. What is the ratio of the General Parity Index (GPI) in Albania in 2005 to that in 2007?
Give a very brief answer. 0.99. What is the ratio of the General Parity Index (GPI) of Philippines in 2005 to that in 2007?
Your answer should be very brief. 1.01. What is the ratio of the General Parity Index (GPI) of Samoa in 2005 to that in 2007?
Offer a very short reply. 0.97. What is the ratio of the General Parity Index (GPI) in Middle East & North Africa (all income levels) in 2006 to that in 2007?
Make the answer very short. 0.98. What is the ratio of the General Parity Index (GPI) of Albania in 2006 to that in 2007?
Ensure brevity in your answer.  0.99. What is the ratio of the General Parity Index (GPI) in Philippines in 2006 to that in 2007?
Offer a very short reply. 1.01. What is the ratio of the General Parity Index (GPI) in Samoa in 2006 to that in 2007?
Ensure brevity in your answer.  0.99. What is the difference between the highest and the second highest General Parity Index (GPI) in Middle East & North Africa (all income levels)?
Ensure brevity in your answer.  0.01. What is the difference between the highest and the second highest General Parity Index (GPI) of Albania?
Keep it short and to the point. 0.01. What is the difference between the highest and the second highest General Parity Index (GPI) in Philippines?
Ensure brevity in your answer.  0. What is the difference between the highest and the second highest General Parity Index (GPI) in Samoa?
Your response must be concise. 0.01. What is the difference between the highest and the lowest General Parity Index (GPI) of Middle East & North Africa (all income levels)?
Offer a terse response. 0.06. What is the difference between the highest and the lowest General Parity Index (GPI) in Albania?
Give a very brief answer. 0.02. What is the difference between the highest and the lowest General Parity Index (GPI) of Philippines?
Ensure brevity in your answer.  0.02. What is the difference between the highest and the lowest General Parity Index (GPI) in Samoa?
Your answer should be compact. 0.04. 